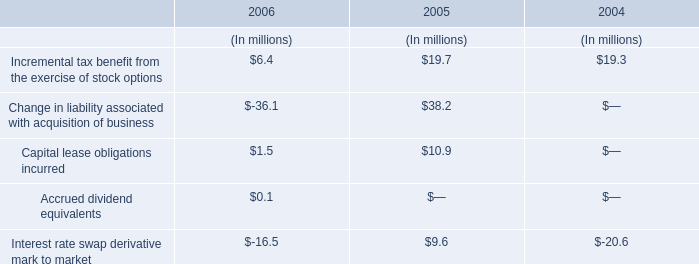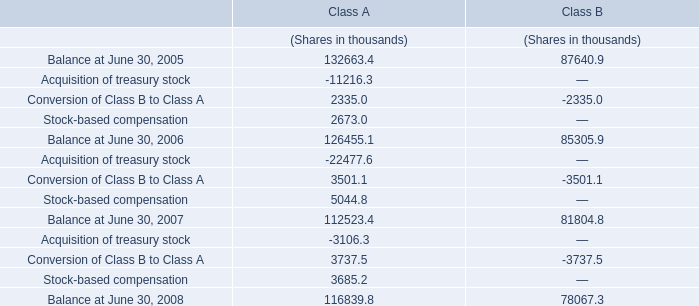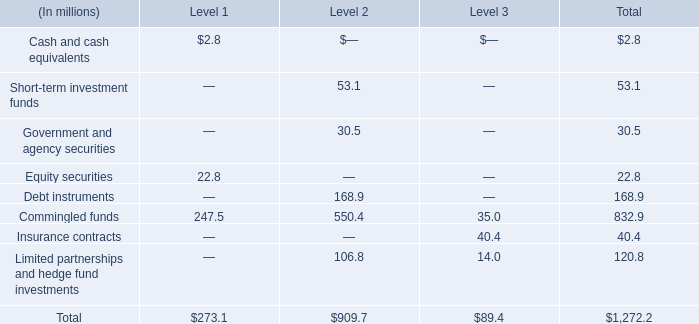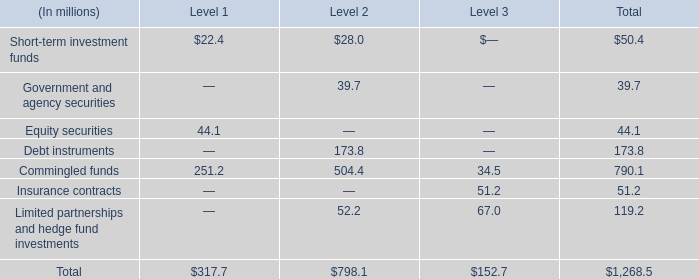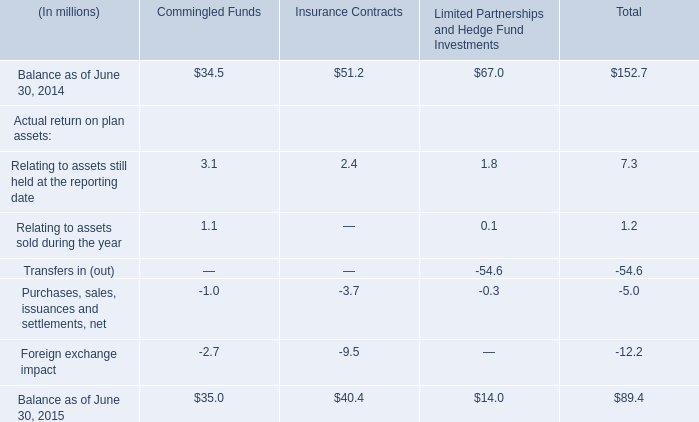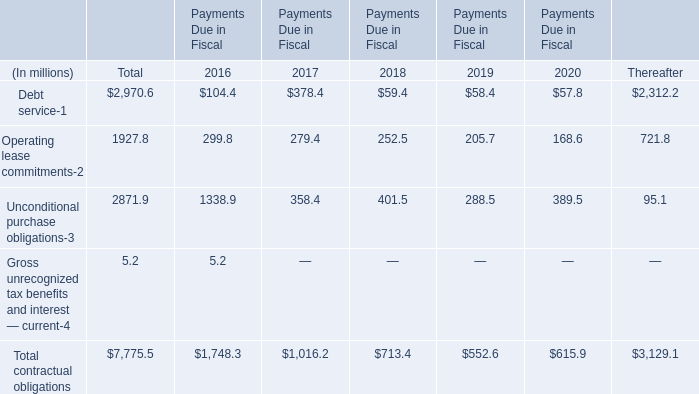What is the proportion of all elements that are greater than 100 to the total amount of elements, in section Total? 
Computations: (((173.8 + 790.1) + 119.2) / 1268.5)
Answer: 0.85384. 